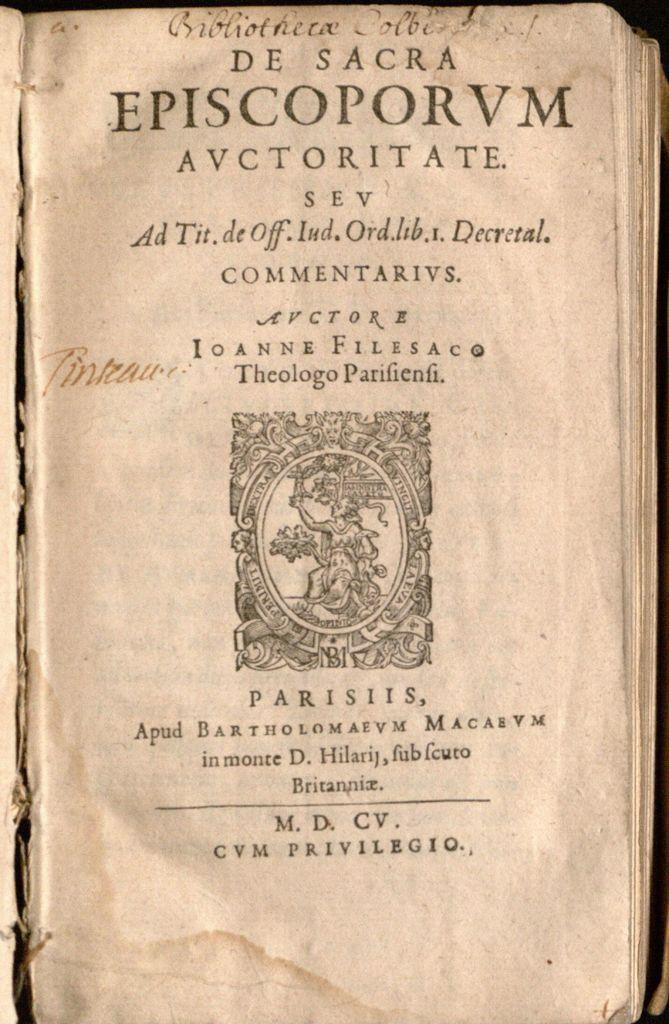What three letter precede privilegio?
Make the answer very short. Cvm. 